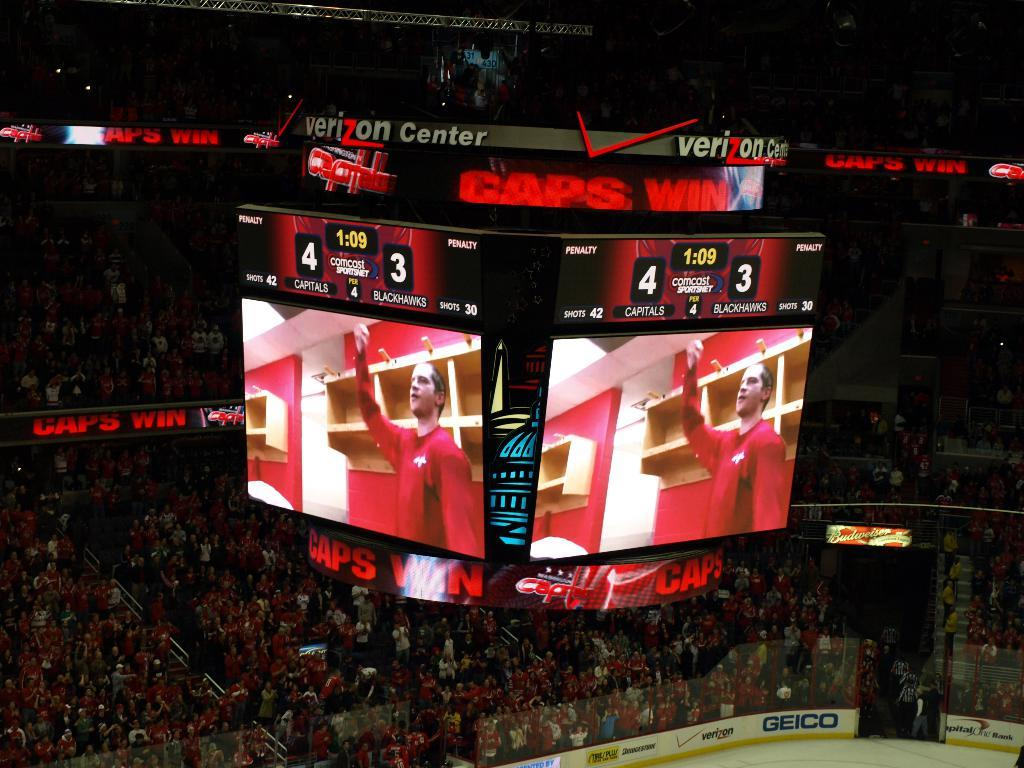<image>
Relay a brief, clear account of the picture shown. A central roof mounted four sided scoreboard at the Verizon center showing the Caps win. 